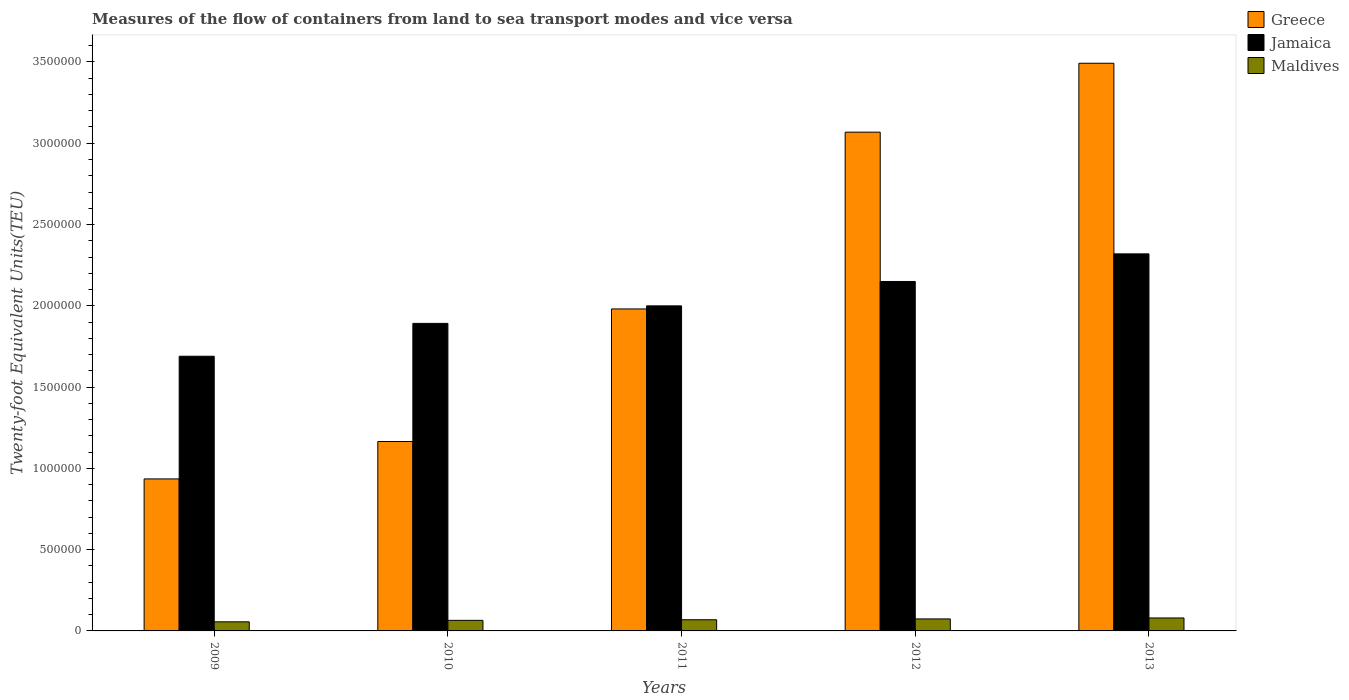How many different coloured bars are there?
Your answer should be very brief. 3. How many groups of bars are there?
Make the answer very short. 5. Are the number of bars per tick equal to the number of legend labels?
Your answer should be very brief. Yes. Are the number of bars on each tick of the X-axis equal?
Provide a succinct answer. Yes. In how many cases, is the number of bars for a given year not equal to the number of legend labels?
Keep it short and to the point. 0. What is the container port traffic in Jamaica in 2013?
Make the answer very short. 2.32e+06. Across all years, what is the maximum container port traffic in Jamaica?
Keep it short and to the point. 2.32e+06. Across all years, what is the minimum container port traffic in Jamaica?
Your answer should be compact. 1.69e+06. In which year was the container port traffic in Maldives maximum?
Provide a short and direct response. 2013. What is the total container port traffic in Jamaica in the graph?
Keep it short and to the point. 1.00e+07. What is the difference between the container port traffic in Maldives in 2009 and that in 2013?
Keep it short and to the point. -2.37e+04. What is the difference between the container port traffic in Jamaica in 2010 and the container port traffic in Greece in 2012?
Your answer should be compact. -1.18e+06. What is the average container port traffic in Jamaica per year?
Give a very brief answer. 2.01e+06. In the year 2011, what is the difference between the container port traffic in Greece and container port traffic in Jamaica?
Your answer should be very brief. -1.90e+04. In how many years, is the container port traffic in Jamaica greater than 100000 TEU?
Your answer should be compact. 5. What is the ratio of the container port traffic in Greece in 2009 to that in 2010?
Offer a terse response. 0.8. Is the container port traffic in Maldives in 2009 less than that in 2012?
Provide a succinct answer. Yes. Is the difference between the container port traffic in Greece in 2011 and 2012 greater than the difference between the container port traffic in Jamaica in 2011 and 2012?
Your answer should be compact. No. What is the difference between the highest and the second highest container port traffic in Jamaica?
Offer a terse response. 1.70e+05. What is the difference between the highest and the lowest container port traffic in Jamaica?
Ensure brevity in your answer.  6.30e+05. In how many years, is the container port traffic in Greece greater than the average container port traffic in Greece taken over all years?
Your response must be concise. 2. Is the sum of the container port traffic in Maldives in 2009 and 2013 greater than the maximum container port traffic in Greece across all years?
Make the answer very short. No. What does the 3rd bar from the left in 2011 represents?
Provide a short and direct response. Maldives. What does the 1st bar from the right in 2012 represents?
Provide a short and direct response. Maldives. Is it the case that in every year, the sum of the container port traffic in Jamaica and container port traffic in Maldives is greater than the container port traffic in Greece?
Provide a short and direct response. No. Are all the bars in the graph horizontal?
Give a very brief answer. No. How many years are there in the graph?
Your response must be concise. 5. What is the difference between two consecutive major ticks on the Y-axis?
Provide a short and direct response. 5.00e+05. How many legend labels are there?
Keep it short and to the point. 3. How are the legend labels stacked?
Give a very brief answer. Vertical. What is the title of the graph?
Your answer should be compact. Measures of the flow of containers from land to sea transport modes and vice versa. Does "Guinea-Bissau" appear as one of the legend labels in the graph?
Give a very brief answer. No. What is the label or title of the X-axis?
Keep it short and to the point. Years. What is the label or title of the Y-axis?
Give a very brief answer. Twenty-foot Equivalent Units(TEU). What is the Twenty-foot Equivalent Units(TEU) of Greece in 2009?
Provide a succinct answer. 9.35e+05. What is the Twenty-foot Equivalent Units(TEU) of Jamaica in 2009?
Offer a very short reply. 1.69e+06. What is the Twenty-foot Equivalent Units(TEU) in Maldives in 2009?
Give a very brief answer. 5.60e+04. What is the Twenty-foot Equivalent Units(TEU) of Greece in 2010?
Your answer should be very brief. 1.17e+06. What is the Twenty-foot Equivalent Units(TEU) of Jamaica in 2010?
Offer a very short reply. 1.89e+06. What is the Twenty-foot Equivalent Units(TEU) in Maldives in 2010?
Give a very brief answer. 6.50e+04. What is the Twenty-foot Equivalent Units(TEU) of Greece in 2011?
Your response must be concise. 1.98e+06. What is the Twenty-foot Equivalent Units(TEU) in Jamaica in 2011?
Your answer should be very brief. 2.00e+06. What is the Twenty-foot Equivalent Units(TEU) in Maldives in 2011?
Provide a short and direct response. 6.87e+04. What is the Twenty-foot Equivalent Units(TEU) of Greece in 2012?
Make the answer very short. 3.07e+06. What is the Twenty-foot Equivalent Units(TEU) in Jamaica in 2012?
Keep it short and to the point. 2.15e+06. What is the Twenty-foot Equivalent Units(TEU) of Maldives in 2012?
Offer a terse response. 7.39e+04. What is the Twenty-foot Equivalent Units(TEU) in Greece in 2013?
Your response must be concise. 3.49e+06. What is the Twenty-foot Equivalent Units(TEU) in Jamaica in 2013?
Your answer should be very brief. 2.32e+06. What is the Twenty-foot Equivalent Units(TEU) of Maldives in 2013?
Make the answer very short. 7.97e+04. Across all years, what is the maximum Twenty-foot Equivalent Units(TEU) in Greece?
Ensure brevity in your answer.  3.49e+06. Across all years, what is the maximum Twenty-foot Equivalent Units(TEU) of Jamaica?
Offer a terse response. 2.32e+06. Across all years, what is the maximum Twenty-foot Equivalent Units(TEU) of Maldives?
Offer a terse response. 7.97e+04. Across all years, what is the minimum Twenty-foot Equivalent Units(TEU) in Greece?
Provide a succinct answer. 9.35e+05. Across all years, what is the minimum Twenty-foot Equivalent Units(TEU) of Jamaica?
Make the answer very short. 1.69e+06. Across all years, what is the minimum Twenty-foot Equivalent Units(TEU) of Maldives?
Offer a terse response. 5.60e+04. What is the total Twenty-foot Equivalent Units(TEU) in Greece in the graph?
Ensure brevity in your answer.  1.06e+07. What is the total Twenty-foot Equivalent Units(TEU) in Jamaica in the graph?
Offer a terse response. 1.00e+07. What is the total Twenty-foot Equivalent Units(TEU) of Maldives in the graph?
Your response must be concise. 3.43e+05. What is the difference between the Twenty-foot Equivalent Units(TEU) of Greece in 2009 and that in 2010?
Your answer should be compact. -2.30e+05. What is the difference between the Twenty-foot Equivalent Units(TEU) in Jamaica in 2009 and that in 2010?
Provide a short and direct response. -2.02e+05. What is the difference between the Twenty-foot Equivalent Units(TEU) of Maldives in 2009 and that in 2010?
Keep it short and to the point. -9016. What is the difference between the Twenty-foot Equivalent Units(TEU) in Greece in 2009 and that in 2011?
Your response must be concise. -1.05e+06. What is the difference between the Twenty-foot Equivalent Units(TEU) of Jamaica in 2009 and that in 2011?
Your response must be concise. -3.10e+05. What is the difference between the Twenty-foot Equivalent Units(TEU) in Maldives in 2009 and that in 2011?
Ensure brevity in your answer.  -1.27e+04. What is the difference between the Twenty-foot Equivalent Units(TEU) of Greece in 2009 and that in 2012?
Your answer should be compact. -2.13e+06. What is the difference between the Twenty-foot Equivalent Units(TEU) of Jamaica in 2009 and that in 2012?
Offer a terse response. -4.60e+05. What is the difference between the Twenty-foot Equivalent Units(TEU) in Maldives in 2009 and that in 2012?
Provide a succinct answer. -1.79e+04. What is the difference between the Twenty-foot Equivalent Units(TEU) in Greece in 2009 and that in 2013?
Ensure brevity in your answer.  -2.56e+06. What is the difference between the Twenty-foot Equivalent Units(TEU) in Jamaica in 2009 and that in 2013?
Give a very brief answer. -6.30e+05. What is the difference between the Twenty-foot Equivalent Units(TEU) of Maldives in 2009 and that in 2013?
Give a very brief answer. -2.37e+04. What is the difference between the Twenty-foot Equivalent Units(TEU) of Greece in 2010 and that in 2011?
Offer a terse response. -8.15e+05. What is the difference between the Twenty-foot Equivalent Units(TEU) of Jamaica in 2010 and that in 2011?
Your answer should be very brief. -1.08e+05. What is the difference between the Twenty-foot Equivalent Units(TEU) of Maldives in 2010 and that in 2011?
Provide a succinct answer. -3705.91. What is the difference between the Twenty-foot Equivalent Units(TEU) in Greece in 2010 and that in 2012?
Offer a terse response. -1.90e+06. What is the difference between the Twenty-foot Equivalent Units(TEU) in Jamaica in 2010 and that in 2012?
Keep it short and to the point. -2.58e+05. What is the difference between the Twenty-foot Equivalent Units(TEU) in Maldives in 2010 and that in 2012?
Offer a terse response. -8860.06. What is the difference between the Twenty-foot Equivalent Units(TEU) in Greece in 2010 and that in 2013?
Your answer should be compact. -2.33e+06. What is the difference between the Twenty-foot Equivalent Units(TEU) in Jamaica in 2010 and that in 2013?
Make the answer very short. -4.28e+05. What is the difference between the Twenty-foot Equivalent Units(TEU) of Maldives in 2010 and that in 2013?
Offer a terse response. -1.47e+04. What is the difference between the Twenty-foot Equivalent Units(TEU) of Greece in 2011 and that in 2012?
Offer a terse response. -1.09e+06. What is the difference between the Twenty-foot Equivalent Units(TEU) of Jamaica in 2011 and that in 2012?
Offer a terse response. -1.50e+05. What is the difference between the Twenty-foot Equivalent Units(TEU) in Maldives in 2011 and that in 2012?
Make the answer very short. -5154.14. What is the difference between the Twenty-foot Equivalent Units(TEU) in Greece in 2011 and that in 2013?
Provide a succinct answer. -1.51e+06. What is the difference between the Twenty-foot Equivalent Units(TEU) of Jamaica in 2011 and that in 2013?
Your answer should be very brief. -3.20e+05. What is the difference between the Twenty-foot Equivalent Units(TEU) in Maldives in 2011 and that in 2013?
Your answer should be very brief. -1.10e+04. What is the difference between the Twenty-foot Equivalent Units(TEU) of Greece in 2012 and that in 2013?
Keep it short and to the point. -4.24e+05. What is the difference between the Twenty-foot Equivalent Units(TEU) of Jamaica in 2012 and that in 2013?
Keep it short and to the point. -1.70e+05. What is the difference between the Twenty-foot Equivalent Units(TEU) of Maldives in 2012 and that in 2013?
Give a very brief answer. -5836.21. What is the difference between the Twenty-foot Equivalent Units(TEU) in Greece in 2009 and the Twenty-foot Equivalent Units(TEU) in Jamaica in 2010?
Offer a terse response. -9.57e+05. What is the difference between the Twenty-foot Equivalent Units(TEU) in Greece in 2009 and the Twenty-foot Equivalent Units(TEU) in Maldives in 2010?
Give a very brief answer. 8.70e+05. What is the difference between the Twenty-foot Equivalent Units(TEU) of Jamaica in 2009 and the Twenty-foot Equivalent Units(TEU) of Maldives in 2010?
Provide a short and direct response. 1.62e+06. What is the difference between the Twenty-foot Equivalent Units(TEU) of Greece in 2009 and the Twenty-foot Equivalent Units(TEU) of Jamaica in 2011?
Give a very brief answer. -1.06e+06. What is the difference between the Twenty-foot Equivalent Units(TEU) of Greece in 2009 and the Twenty-foot Equivalent Units(TEU) of Maldives in 2011?
Make the answer very short. 8.66e+05. What is the difference between the Twenty-foot Equivalent Units(TEU) of Jamaica in 2009 and the Twenty-foot Equivalent Units(TEU) of Maldives in 2011?
Offer a very short reply. 1.62e+06. What is the difference between the Twenty-foot Equivalent Units(TEU) of Greece in 2009 and the Twenty-foot Equivalent Units(TEU) of Jamaica in 2012?
Your answer should be very brief. -1.21e+06. What is the difference between the Twenty-foot Equivalent Units(TEU) of Greece in 2009 and the Twenty-foot Equivalent Units(TEU) of Maldives in 2012?
Your answer should be compact. 8.61e+05. What is the difference between the Twenty-foot Equivalent Units(TEU) of Jamaica in 2009 and the Twenty-foot Equivalent Units(TEU) of Maldives in 2012?
Keep it short and to the point. 1.62e+06. What is the difference between the Twenty-foot Equivalent Units(TEU) of Greece in 2009 and the Twenty-foot Equivalent Units(TEU) of Jamaica in 2013?
Offer a very short reply. -1.38e+06. What is the difference between the Twenty-foot Equivalent Units(TEU) in Greece in 2009 and the Twenty-foot Equivalent Units(TEU) in Maldives in 2013?
Offer a terse response. 8.55e+05. What is the difference between the Twenty-foot Equivalent Units(TEU) of Jamaica in 2009 and the Twenty-foot Equivalent Units(TEU) of Maldives in 2013?
Your response must be concise. 1.61e+06. What is the difference between the Twenty-foot Equivalent Units(TEU) in Greece in 2010 and the Twenty-foot Equivalent Units(TEU) in Jamaica in 2011?
Give a very brief answer. -8.34e+05. What is the difference between the Twenty-foot Equivalent Units(TEU) in Greece in 2010 and the Twenty-foot Equivalent Units(TEU) in Maldives in 2011?
Offer a terse response. 1.10e+06. What is the difference between the Twenty-foot Equivalent Units(TEU) of Jamaica in 2010 and the Twenty-foot Equivalent Units(TEU) of Maldives in 2011?
Your answer should be very brief. 1.82e+06. What is the difference between the Twenty-foot Equivalent Units(TEU) in Greece in 2010 and the Twenty-foot Equivalent Units(TEU) in Jamaica in 2012?
Provide a short and direct response. -9.84e+05. What is the difference between the Twenty-foot Equivalent Units(TEU) in Greece in 2010 and the Twenty-foot Equivalent Units(TEU) in Maldives in 2012?
Offer a very short reply. 1.09e+06. What is the difference between the Twenty-foot Equivalent Units(TEU) in Jamaica in 2010 and the Twenty-foot Equivalent Units(TEU) in Maldives in 2012?
Offer a terse response. 1.82e+06. What is the difference between the Twenty-foot Equivalent Units(TEU) in Greece in 2010 and the Twenty-foot Equivalent Units(TEU) in Jamaica in 2013?
Your answer should be compact. -1.15e+06. What is the difference between the Twenty-foot Equivalent Units(TEU) of Greece in 2010 and the Twenty-foot Equivalent Units(TEU) of Maldives in 2013?
Provide a short and direct response. 1.09e+06. What is the difference between the Twenty-foot Equivalent Units(TEU) of Jamaica in 2010 and the Twenty-foot Equivalent Units(TEU) of Maldives in 2013?
Offer a terse response. 1.81e+06. What is the difference between the Twenty-foot Equivalent Units(TEU) in Greece in 2011 and the Twenty-foot Equivalent Units(TEU) in Jamaica in 2012?
Your response must be concise. -1.69e+05. What is the difference between the Twenty-foot Equivalent Units(TEU) of Greece in 2011 and the Twenty-foot Equivalent Units(TEU) of Maldives in 2012?
Provide a succinct answer. 1.91e+06. What is the difference between the Twenty-foot Equivalent Units(TEU) of Jamaica in 2011 and the Twenty-foot Equivalent Units(TEU) of Maldives in 2012?
Offer a terse response. 1.93e+06. What is the difference between the Twenty-foot Equivalent Units(TEU) of Greece in 2011 and the Twenty-foot Equivalent Units(TEU) of Jamaica in 2013?
Make the answer very short. -3.39e+05. What is the difference between the Twenty-foot Equivalent Units(TEU) of Greece in 2011 and the Twenty-foot Equivalent Units(TEU) of Maldives in 2013?
Offer a terse response. 1.90e+06. What is the difference between the Twenty-foot Equivalent Units(TEU) in Jamaica in 2011 and the Twenty-foot Equivalent Units(TEU) in Maldives in 2013?
Offer a very short reply. 1.92e+06. What is the difference between the Twenty-foot Equivalent Units(TEU) of Greece in 2012 and the Twenty-foot Equivalent Units(TEU) of Jamaica in 2013?
Make the answer very short. 7.49e+05. What is the difference between the Twenty-foot Equivalent Units(TEU) of Greece in 2012 and the Twenty-foot Equivalent Units(TEU) of Maldives in 2013?
Offer a very short reply. 2.99e+06. What is the difference between the Twenty-foot Equivalent Units(TEU) of Jamaica in 2012 and the Twenty-foot Equivalent Units(TEU) of Maldives in 2013?
Offer a terse response. 2.07e+06. What is the average Twenty-foot Equivalent Units(TEU) of Greece per year?
Your answer should be compact. 2.13e+06. What is the average Twenty-foot Equivalent Units(TEU) in Jamaica per year?
Ensure brevity in your answer.  2.01e+06. What is the average Twenty-foot Equivalent Units(TEU) in Maldives per year?
Your answer should be compact. 6.87e+04. In the year 2009, what is the difference between the Twenty-foot Equivalent Units(TEU) in Greece and Twenty-foot Equivalent Units(TEU) in Jamaica?
Your response must be concise. -7.55e+05. In the year 2009, what is the difference between the Twenty-foot Equivalent Units(TEU) of Greece and Twenty-foot Equivalent Units(TEU) of Maldives?
Make the answer very short. 8.79e+05. In the year 2009, what is the difference between the Twenty-foot Equivalent Units(TEU) in Jamaica and Twenty-foot Equivalent Units(TEU) in Maldives?
Provide a succinct answer. 1.63e+06. In the year 2010, what is the difference between the Twenty-foot Equivalent Units(TEU) in Greece and Twenty-foot Equivalent Units(TEU) in Jamaica?
Ensure brevity in your answer.  -7.27e+05. In the year 2010, what is the difference between the Twenty-foot Equivalent Units(TEU) of Greece and Twenty-foot Equivalent Units(TEU) of Maldives?
Provide a succinct answer. 1.10e+06. In the year 2010, what is the difference between the Twenty-foot Equivalent Units(TEU) of Jamaica and Twenty-foot Equivalent Units(TEU) of Maldives?
Keep it short and to the point. 1.83e+06. In the year 2011, what is the difference between the Twenty-foot Equivalent Units(TEU) of Greece and Twenty-foot Equivalent Units(TEU) of Jamaica?
Provide a succinct answer. -1.90e+04. In the year 2011, what is the difference between the Twenty-foot Equivalent Units(TEU) of Greece and Twenty-foot Equivalent Units(TEU) of Maldives?
Ensure brevity in your answer.  1.91e+06. In the year 2011, what is the difference between the Twenty-foot Equivalent Units(TEU) of Jamaica and Twenty-foot Equivalent Units(TEU) of Maldives?
Offer a terse response. 1.93e+06. In the year 2012, what is the difference between the Twenty-foot Equivalent Units(TEU) in Greece and Twenty-foot Equivalent Units(TEU) in Jamaica?
Provide a short and direct response. 9.18e+05. In the year 2012, what is the difference between the Twenty-foot Equivalent Units(TEU) in Greece and Twenty-foot Equivalent Units(TEU) in Maldives?
Provide a succinct answer. 2.99e+06. In the year 2012, what is the difference between the Twenty-foot Equivalent Units(TEU) of Jamaica and Twenty-foot Equivalent Units(TEU) of Maldives?
Your answer should be compact. 2.08e+06. In the year 2013, what is the difference between the Twenty-foot Equivalent Units(TEU) in Greece and Twenty-foot Equivalent Units(TEU) in Jamaica?
Give a very brief answer. 1.17e+06. In the year 2013, what is the difference between the Twenty-foot Equivalent Units(TEU) in Greece and Twenty-foot Equivalent Units(TEU) in Maldives?
Your response must be concise. 3.41e+06. In the year 2013, what is the difference between the Twenty-foot Equivalent Units(TEU) in Jamaica and Twenty-foot Equivalent Units(TEU) in Maldives?
Keep it short and to the point. 2.24e+06. What is the ratio of the Twenty-foot Equivalent Units(TEU) of Greece in 2009 to that in 2010?
Give a very brief answer. 0.8. What is the ratio of the Twenty-foot Equivalent Units(TEU) in Jamaica in 2009 to that in 2010?
Ensure brevity in your answer.  0.89. What is the ratio of the Twenty-foot Equivalent Units(TEU) of Maldives in 2009 to that in 2010?
Your answer should be compact. 0.86. What is the ratio of the Twenty-foot Equivalent Units(TEU) in Greece in 2009 to that in 2011?
Give a very brief answer. 0.47. What is the ratio of the Twenty-foot Equivalent Units(TEU) in Jamaica in 2009 to that in 2011?
Offer a very short reply. 0.84. What is the ratio of the Twenty-foot Equivalent Units(TEU) of Maldives in 2009 to that in 2011?
Offer a very short reply. 0.81. What is the ratio of the Twenty-foot Equivalent Units(TEU) of Greece in 2009 to that in 2012?
Keep it short and to the point. 0.3. What is the ratio of the Twenty-foot Equivalent Units(TEU) of Jamaica in 2009 to that in 2012?
Your answer should be compact. 0.79. What is the ratio of the Twenty-foot Equivalent Units(TEU) in Maldives in 2009 to that in 2012?
Offer a terse response. 0.76. What is the ratio of the Twenty-foot Equivalent Units(TEU) of Greece in 2009 to that in 2013?
Your response must be concise. 0.27. What is the ratio of the Twenty-foot Equivalent Units(TEU) of Jamaica in 2009 to that in 2013?
Provide a succinct answer. 0.73. What is the ratio of the Twenty-foot Equivalent Units(TEU) of Maldives in 2009 to that in 2013?
Keep it short and to the point. 0.7. What is the ratio of the Twenty-foot Equivalent Units(TEU) in Greece in 2010 to that in 2011?
Offer a terse response. 0.59. What is the ratio of the Twenty-foot Equivalent Units(TEU) of Jamaica in 2010 to that in 2011?
Your response must be concise. 0.95. What is the ratio of the Twenty-foot Equivalent Units(TEU) of Maldives in 2010 to that in 2011?
Offer a terse response. 0.95. What is the ratio of the Twenty-foot Equivalent Units(TEU) in Greece in 2010 to that in 2012?
Your answer should be compact. 0.38. What is the ratio of the Twenty-foot Equivalent Units(TEU) in Jamaica in 2010 to that in 2012?
Your response must be concise. 0.88. What is the ratio of the Twenty-foot Equivalent Units(TEU) in Maldives in 2010 to that in 2012?
Give a very brief answer. 0.88. What is the ratio of the Twenty-foot Equivalent Units(TEU) of Greece in 2010 to that in 2013?
Your answer should be very brief. 0.33. What is the ratio of the Twenty-foot Equivalent Units(TEU) of Jamaica in 2010 to that in 2013?
Make the answer very short. 0.82. What is the ratio of the Twenty-foot Equivalent Units(TEU) in Maldives in 2010 to that in 2013?
Ensure brevity in your answer.  0.82. What is the ratio of the Twenty-foot Equivalent Units(TEU) of Greece in 2011 to that in 2012?
Keep it short and to the point. 0.65. What is the ratio of the Twenty-foot Equivalent Units(TEU) of Jamaica in 2011 to that in 2012?
Offer a very short reply. 0.93. What is the ratio of the Twenty-foot Equivalent Units(TEU) in Maldives in 2011 to that in 2012?
Offer a very short reply. 0.93. What is the ratio of the Twenty-foot Equivalent Units(TEU) in Greece in 2011 to that in 2013?
Offer a terse response. 0.57. What is the ratio of the Twenty-foot Equivalent Units(TEU) of Jamaica in 2011 to that in 2013?
Provide a succinct answer. 0.86. What is the ratio of the Twenty-foot Equivalent Units(TEU) of Maldives in 2011 to that in 2013?
Provide a succinct answer. 0.86. What is the ratio of the Twenty-foot Equivalent Units(TEU) in Greece in 2012 to that in 2013?
Keep it short and to the point. 0.88. What is the ratio of the Twenty-foot Equivalent Units(TEU) in Jamaica in 2012 to that in 2013?
Your response must be concise. 0.93. What is the ratio of the Twenty-foot Equivalent Units(TEU) in Maldives in 2012 to that in 2013?
Offer a terse response. 0.93. What is the difference between the highest and the second highest Twenty-foot Equivalent Units(TEU) of Greece?
Your answer should be compact. 4.24e+05. What is the difference between the highest and the second highest Twenty-foot Equivalent Units(TEU) of Jamaica?
Offer a terse response. 1.70e+05. What is the difference between the highest and the second highest Twenty-foot Equivalent Units(TEU) of Maldives?
Provide a succinct answer. 5836.21. What is the difference between the highest and the lowest Twenty-foot Equivalent Units(TEU) in Greece?
Offer a very short reply. 2.56e+06. What is the difference between the highest and the lowest Twenty-foot Equivalent Units(TEU) in Jamaica?
Your response must be concise. 6.30e+05. What is the difference between the highest and the lowest Twenty-foot Equivalent Units(TEU) in Maldives?
Ensure brevity in your answer.  2.37e+04. 